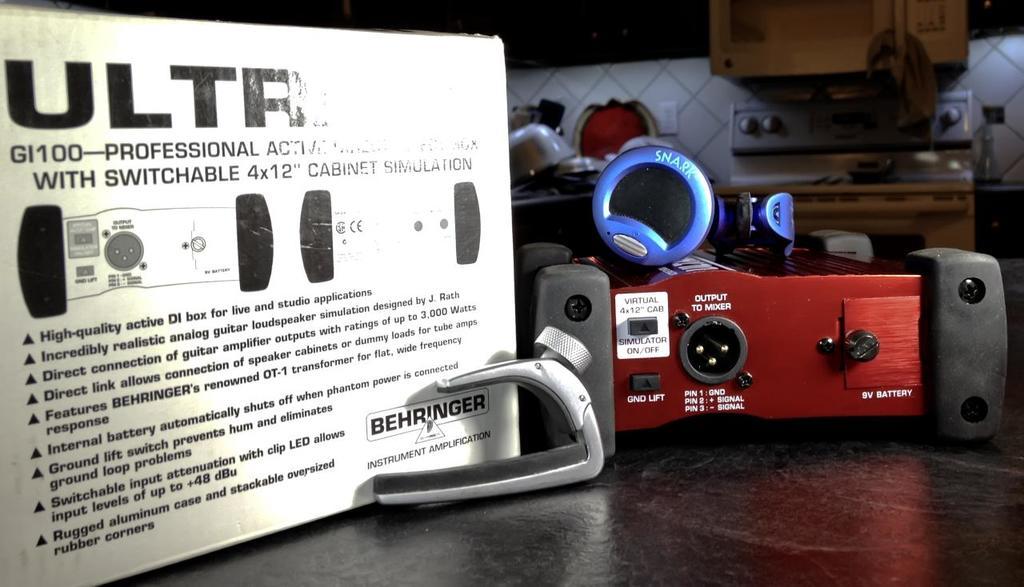What is the model number?
Offer a very short reply. Gi100. 